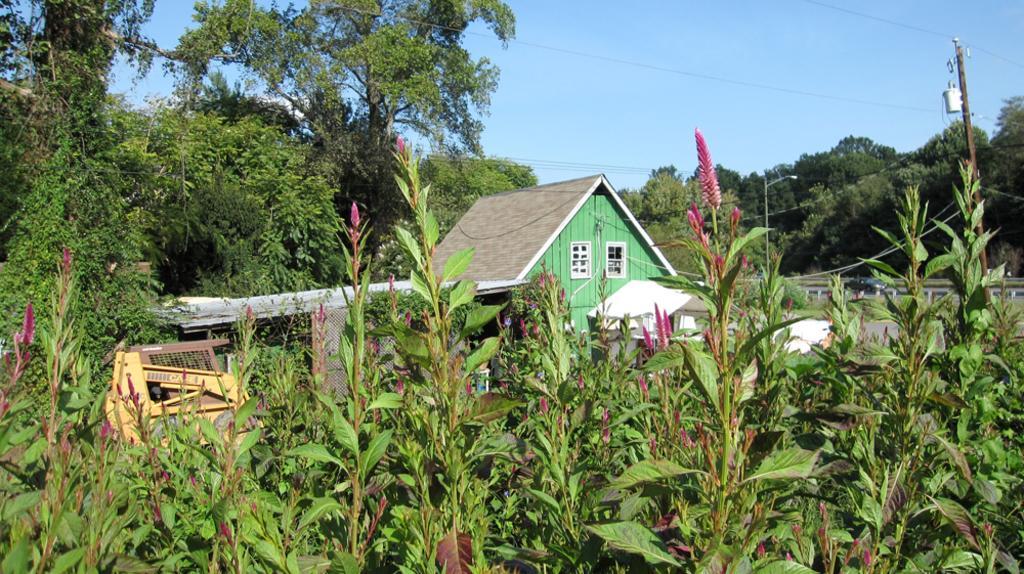Can you describe this image briefly? This picture is taken from the outside of the city. In this image, in the middle, we can see a house, window. On the right side, we can see some trees, plants, electric pole, electric wires. On the right side, we can also see a street light. On the right side, we can see some plants with flowers, trees. In the background, we can also see some wooden instrument. At the top, we can see a sky which is a bit cloudy. 